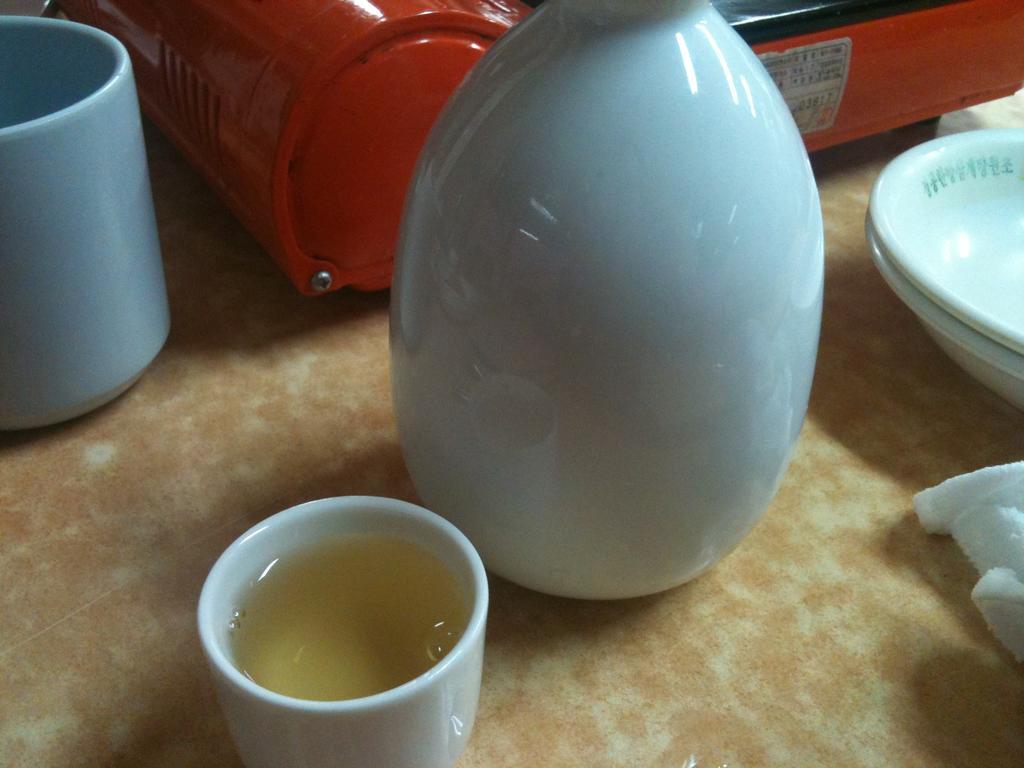How would you summarize this image in a sentence or two? In this picture, it looks like a table and on the table there are cups, cloth, plates, a jar and a red color object. 